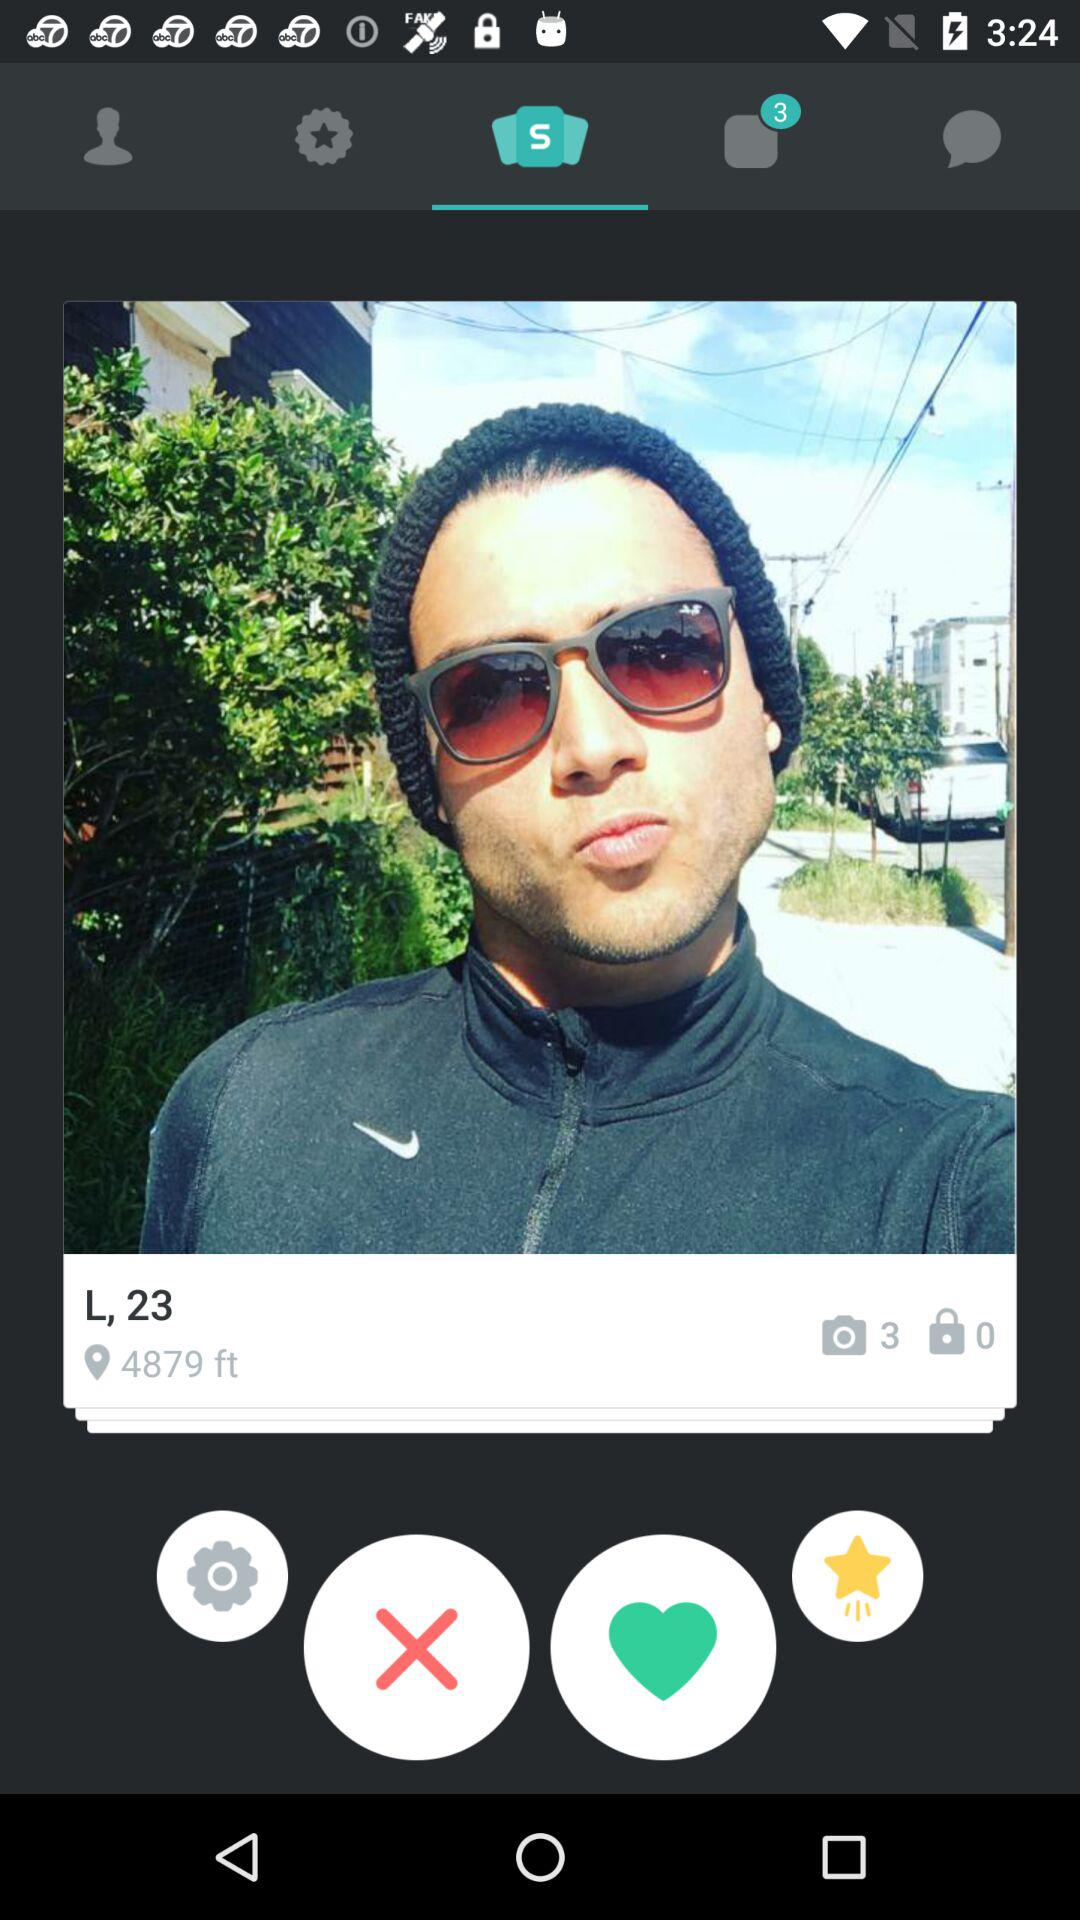How old is the user? The user is 23 years old. 